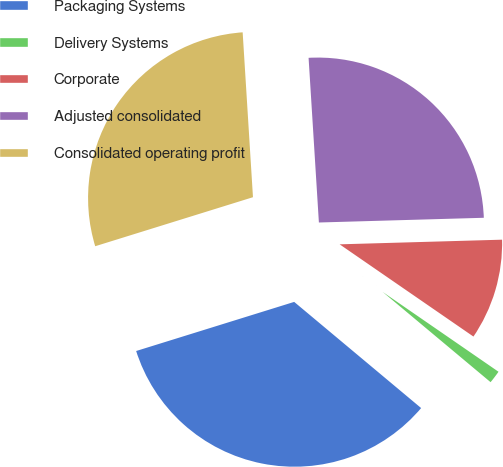Convert chart. <chart><loc_0><loc_0><loc_500><loc_500><pie_chart><fcel>Packaging Systems<fcel>Delivery Systems<fcel>Corporate<fcel>Adjusted consolidated<fcel>Consolidated operating profit<nl><fcel>34.12%<fcel>1.48%<fcel>10.06%<fcel>25.54%<fcel>28.8%<nl></chart> 